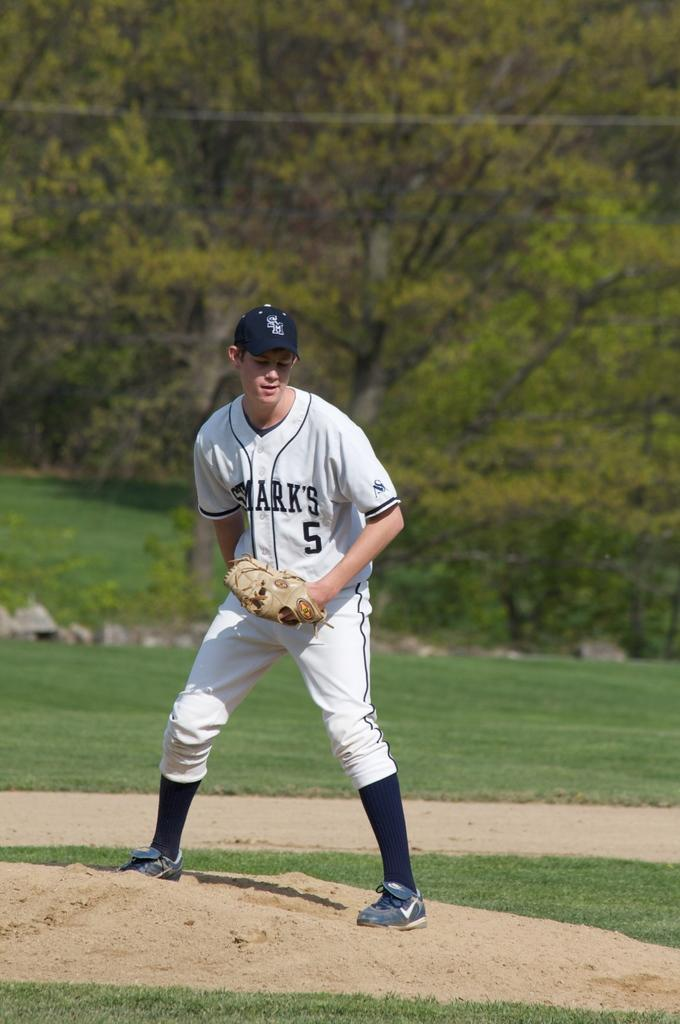<image>
Render a clear and concise summary of the photo. pitcher for st marks number 5 on the pitchers mound 